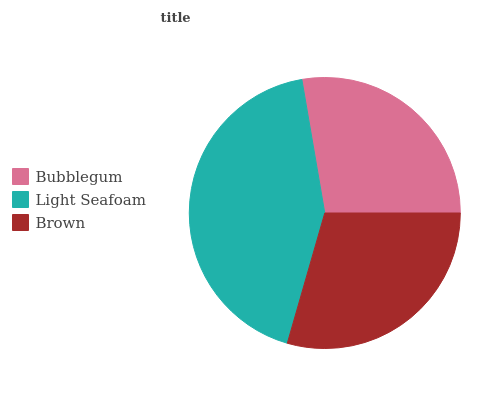Is Bubblegum the minimum?
Answer yes or no. Yes. Is Light Seafoam the maximum?
Answer yes or no. Yes. Is Brown the minimum?
Answer yes or no. No. Is Brown the maximum?
Answer yes or no. No. Is Light Seafoam greater than Brown?
Answer yes or no. Yes. Is Brown less than Light Seafoam?
Answer yes or no. Yes. Is Brown greater than Light Seafoam?
Answer yes or no. No. Is Light Seafoam less than Brown?
Answer yes or no. No. Is Brown the high median?
Answer yes or no. Yes. Is Brown the low median?
Answer yes or no. Yes. Is Light Seafoam the high median?
Answer yes or no. No. Is Light Seafoam the low median?
Answer yes or no. No. 